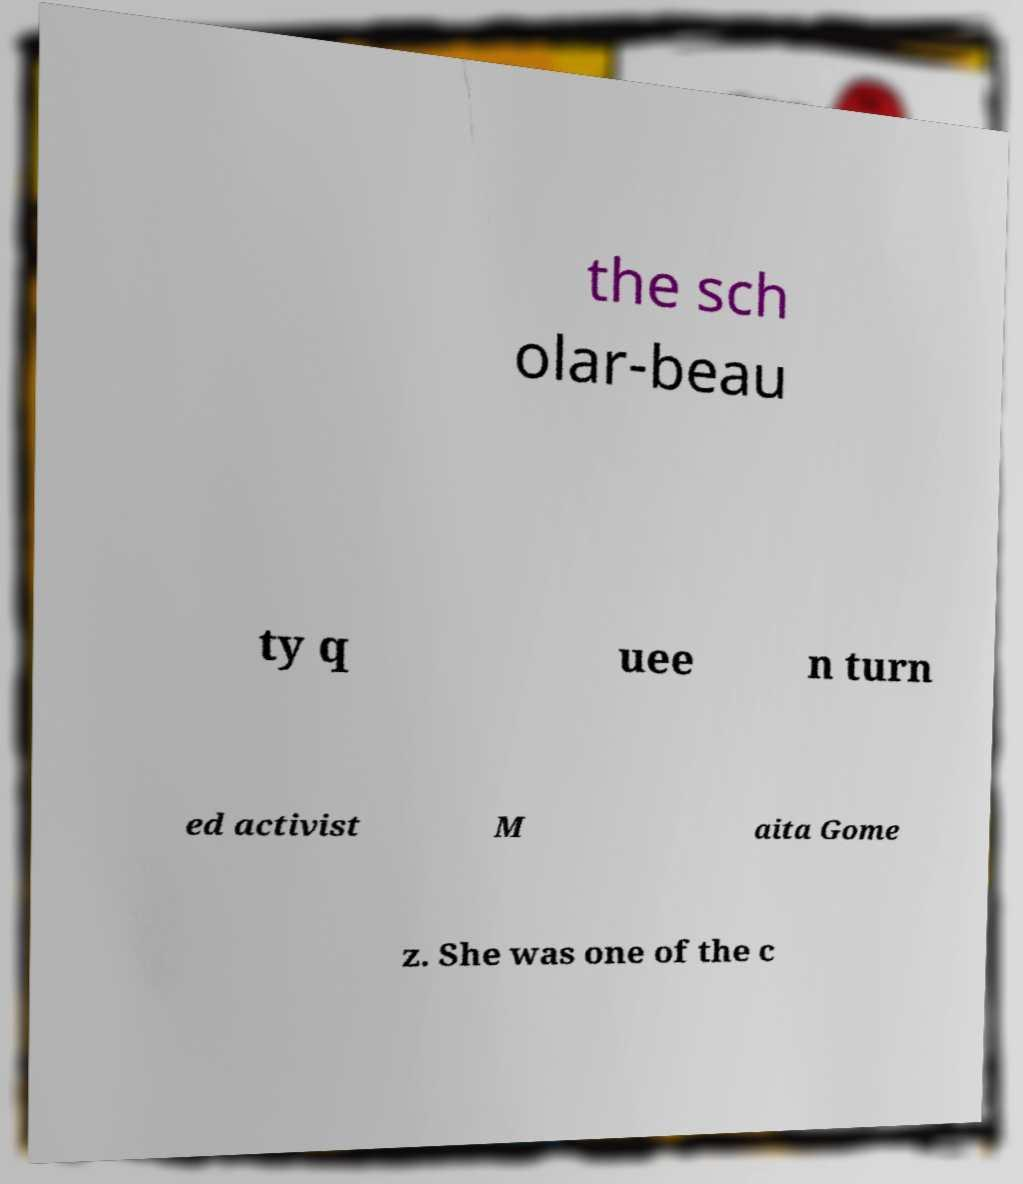Please read and relay the text visible in this image. What does it say? the sch olar-beau ty q uee n turn ed activist M aita Gome z. She was one of the c 